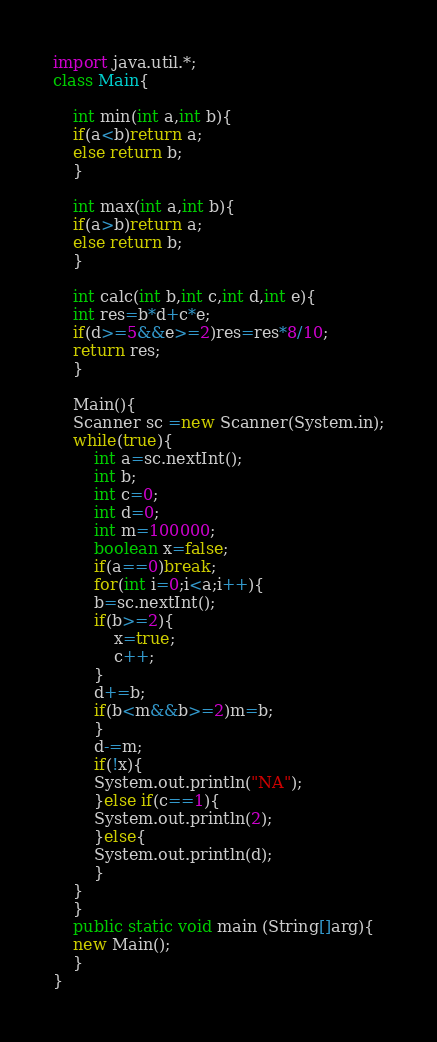Convert code to text. <code><loc_0><loc_0><loc_500><loc_500><_Java_>import java.util.*;
class Main{

    int min(int a,int b){
	if(a<b)return a;
	else return b;
    }

    int max(int a,int b){
	if(a>b)return a;
	else return b;
    }

    int calc(int b,int c,int d,int e){
	int res=b*d+c*e;
	if(d>=5&&e>=2)res=res*8/10;
	return res;
    }

    Main(){
	Scanner sc =new Scanner(System.in);
	while(true){
	    int a=sc.nextInt();
	    int b;
	    int c=0;
	    int d=0;
	    int m=100000;
	    boolean x=false;
	    if(a==0)break;
	    for(int i=0;i<a;i++){
		b=sc.nextInt();
		if(b>=2){
		    x=true;
		    c++;
		}
		d+=b;
		if(b<m&&b>=2)m=b;
	    }
	    d-=m;    
	    if(!x){
		System.out.println("NA");
	    }else if(c==1){
		System.out.println(2);
	    }else{
		System.out.println(d);
	    }
	}
    }
    public static void main (String[]arg){
	new Main();
    }
}</code> 